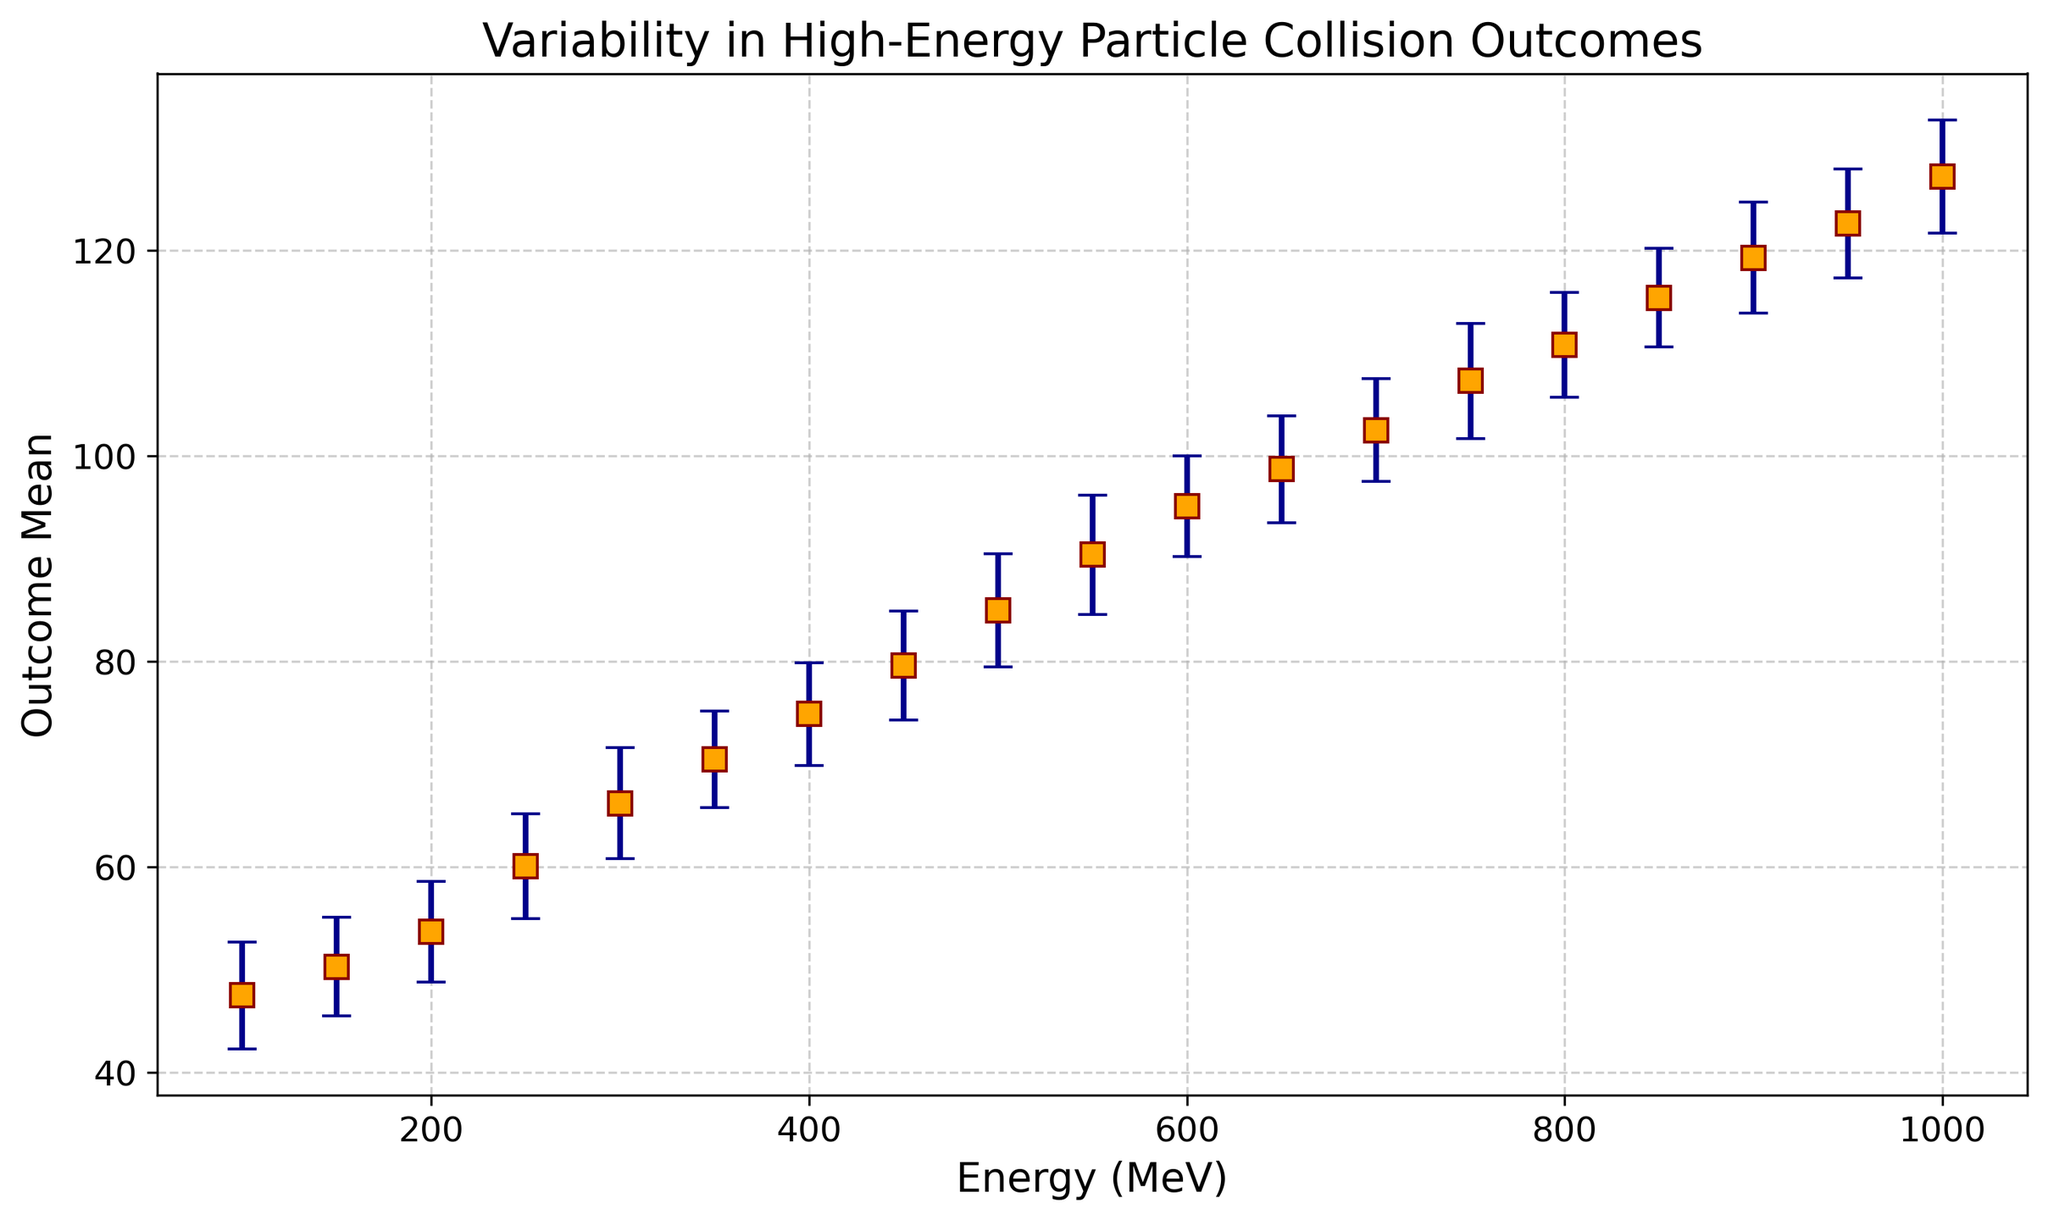What's the mean outcome at 350 MeV? At 350 MeV, the mean outcome value is directly readable from the figure.
Answer: 70.5 Which energy level has the highest mean outcome? By scanning the chart from left to right, we see that 1000 MeV has the highest mean outcome value.
Answer: 1000 MeV What is the difference in mean outcomes between 800 MeV and 600 MeV? The mean outcome at 800 MeV is 110.8 and at 600 MeV is 95.1. The difference is 110.8 - 95.1.
Answer: 15.7 At which energy level do we observe the smallest standard deviation? The smallest error bar, indicating the smallest standard deviation, is observed at 350 MeV.
Answer: 350 MeV What is the total mean outcome for the three highest energy levels? The mean outcomes at 900 MeV, 950 MeV, and 1000 MeV are 119.3, 122.6, and 127.2 respectively. The sum is 119.3 + 122.6 + 127.2.
Answer: 369.1 Which energy level shows the widest range of outcome variation considering the error bars? The widest total error bar length can be observed at 550 MeV, looking at how far the error bars extend on both sides.
Answer: 550 MeV Is there any energy level where the mean outcome is 80 or more? By scanning through the mean outcome values, we observe that from 450 MeV onwards, the mean outcomes are 80 or more.
Answer: Yes How many energy levels have a mean outcome below 60? The energy levels with mean outcomes below 60 are 100, 150, 200, and 250 MeV. There are four such levels.
Answer: 4 What is the mean outcome for energy levels between 400 MeV and 600 MeV inclusive? The mean outcomes for energy levels 400, 450, 500, 550, and 600 MeV are 74.9, 79.6, 85.0, 90.4, and 95.1 respectively. The average is (74.9 + 79.6 + 85.0 + 90.4 + 95.1)/5.
Answer: 85.0 Is the mean outcome at 700 MeV greater than that at 650 MeV? At 700 MeV the mean outcome is 102.5, and at 650 MeV it is 98.7. Since 102.5 is greater than 98.7, the answer is yes.
Answer: Yes 